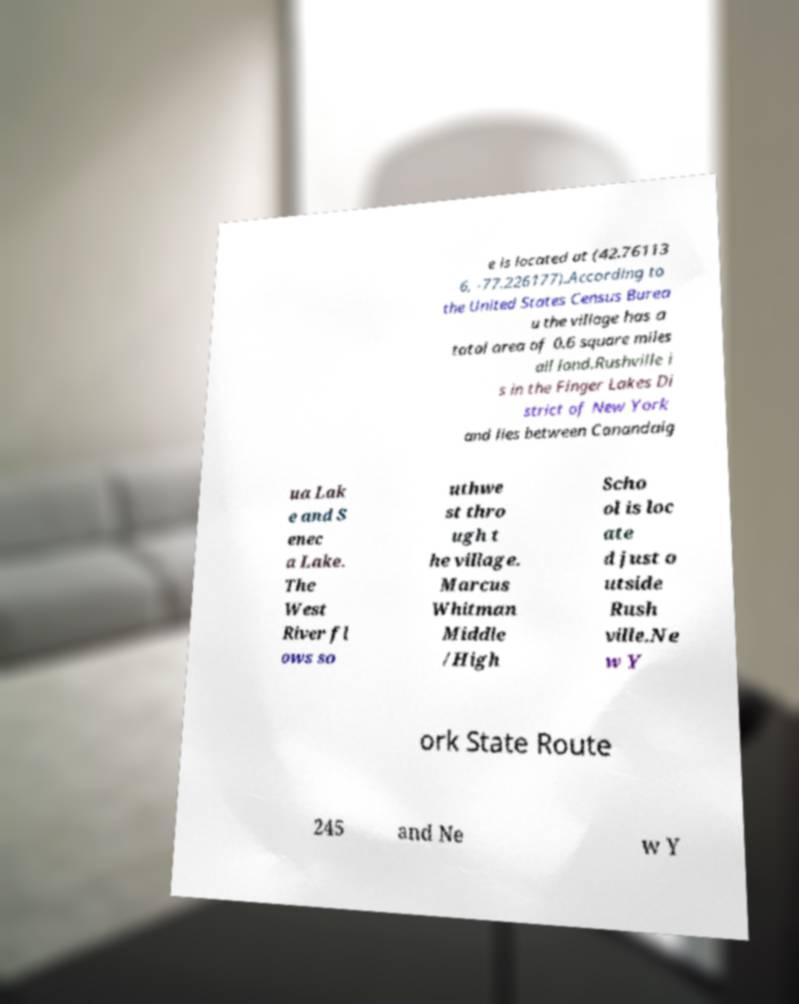What messages or text are displayed in this image? I need them in a readable, typed format. e is located at (42.76113 6, -77.226177).According to the United States Census Burea u the village has a total area of 0.6 square miles all land.Rushville i s in the Finger Lakes Di strict of New York and lies between Canandaig ua Lak e and S enec a Lake. The West River fl ows so uthwe st thro ugh t he village. Marcus Whitman Middle /High Scho ol is loc ate d just o utside Rush ville.Ne w Y ork State Route 245 and Ne w Y 